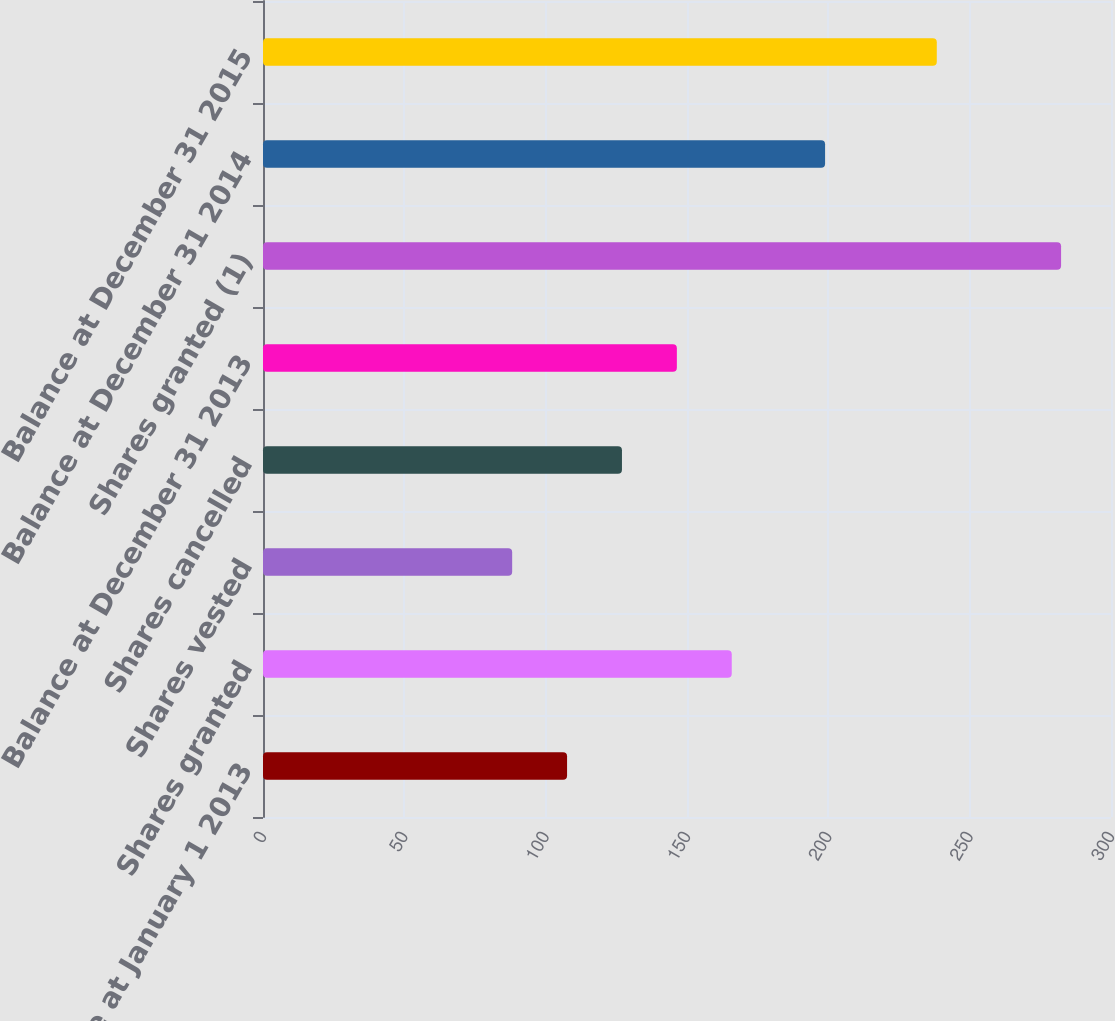Convert chart to OTSL. <chart><loc_0><loc_0><loc_500><loc_500><bar_chart><fcel>Balance at January 1 2013<fcel>Shares granted<fcel>Shares vested<fcel>Shares cancelled<fcel>Balance at December 31 2013<fcel>Shares granted (1)<fcel>Balance at December 31 2014<fcel>Balance at December 31 2015<nl><fcel>107.57<fcel>165.83<fcel>88.15<fcel>126.99<fcel>146.41<fcel>282.34<fcel>198.85<fcel>238.37<nl></chart> 